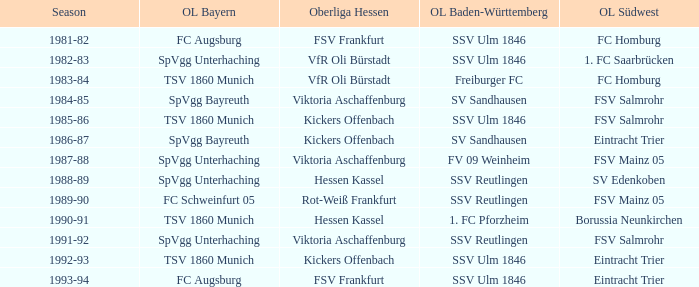Which Oberliga Bayern has a Season of 1981-82? FC Augsburg. 